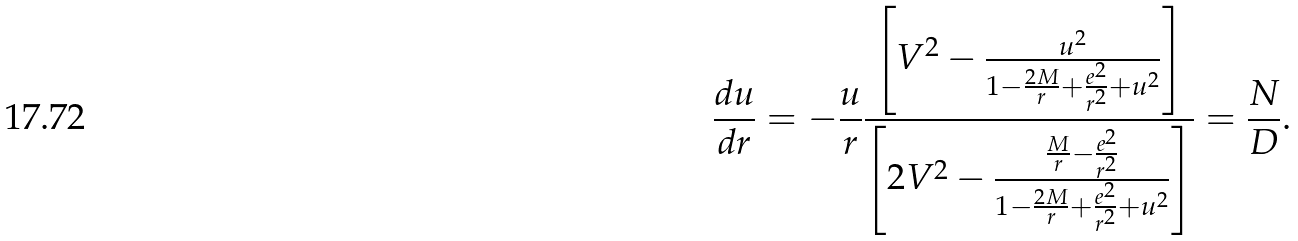Convert formula to latex. <formula><loc_0><loc_0><loc_500><loc_500>\frac { d u } { d r } = - \frac { u } { r } \frac { \left [ V ^ { 2 } - \frac { u ^ { 2 } } { 1 - \frac { 2 M } { r } + \frac { e ^ { 2 } } { r ^ { 2 } } + u ^ { 2 } } \right ] } { \left [ 2 V ^ { 2 } - \frac { \frac { M } { r } - \frac { e ^ { 2 } } { r ^ { 2 } } } { 1 - \frac { 2 M } { r } + \frac { e ^ { 2 } } { r ^ { 2 } } + u ^ { 2 } } \right ] } = \frac { N } { D } .</formula> 